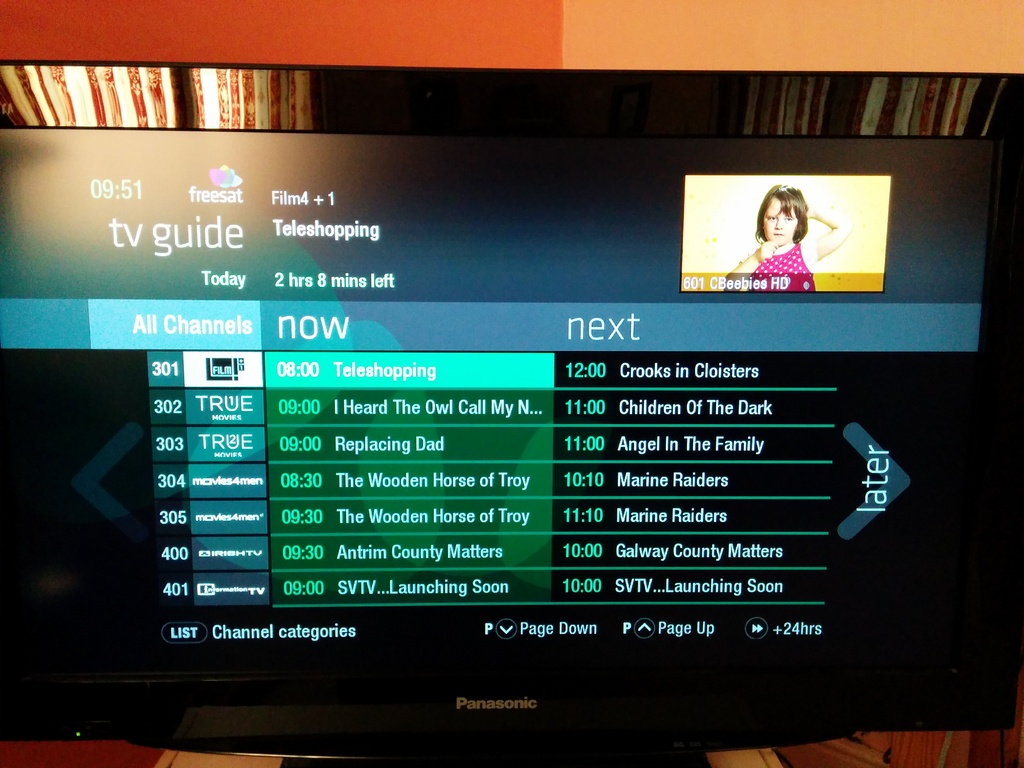What program is currently being displayed as 'now' on Film4 +1 in the TV guide? The program currently displayed as 'now' on Film4 +1 is 'Teleshopping.' 